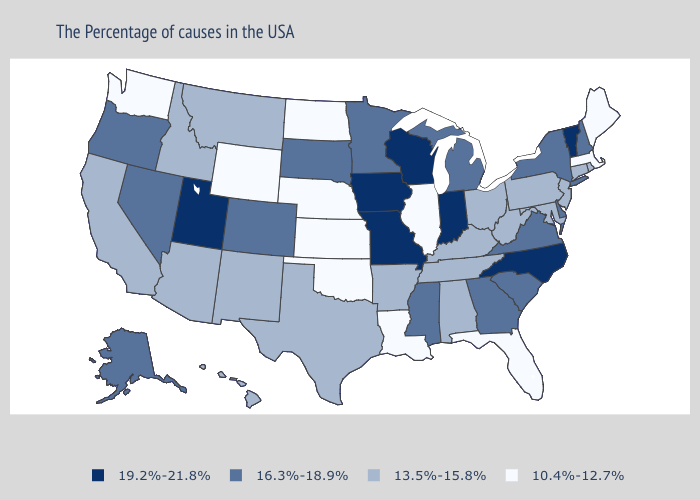Name the states that have a value in the range 19.2%-21.8%?
Give a very brief answer. Vermont, North Carolina, Indiana, Wisconsin, Missouri, Iowa, Utah. Does Idaho have a lower value than Kansas?
Be succinct. No. Does Nebraska have the lowest value in the USA?
Concise answer only. Yes. Does Iowa have the highest value in the USA?
Concise answer only. Yes. Which states hav the highest value in the Northeast?
Give a very brief answer. Vermont. Name the states that have a value in the range 13.5%-15.8%?
Keep it brief. Rhode Island, Connecticut, New Jersey, Maryland, Pennsylvania, West Virginia, Ohio, Kentucky, Alabama, Tennessee, Arkansas, Texas, New Mexico, Montana, Arizona, Idaho, California, Hawaii. Which states have the highest value in the USA?
Be succinct. Vermont, North Carolina, Indiana, Wisconsin, Missouri, Iowa, Utah. What is the value of Michigan?
Give a very brief answer. 16.3%-18.9%. Does Florida have the same value as Illinois?
Concise answer only. Yes. Among the states that border New York , does Connecticut have the lowest value?
Write a very short answer. No. What is the lowest value in the Northeast?
Keep it brief. 10.4%-12.7%. What is the value of Alaska?
Short answer required. 16.3%-18.9%. What is the value of Hawaii?
Write a very short answer. 13.5%-15.8%. Name the states that have a value in the range 10.4%-12.7%?
Give a very brief answer. Maine, Massachusetts, Florida, Illinois, Louisiana, Kansas, Nebraska, Oklahoma, North Dakota, Wyoming, Washington. Is the legend a continuous bar?
Quick response, please. No. 